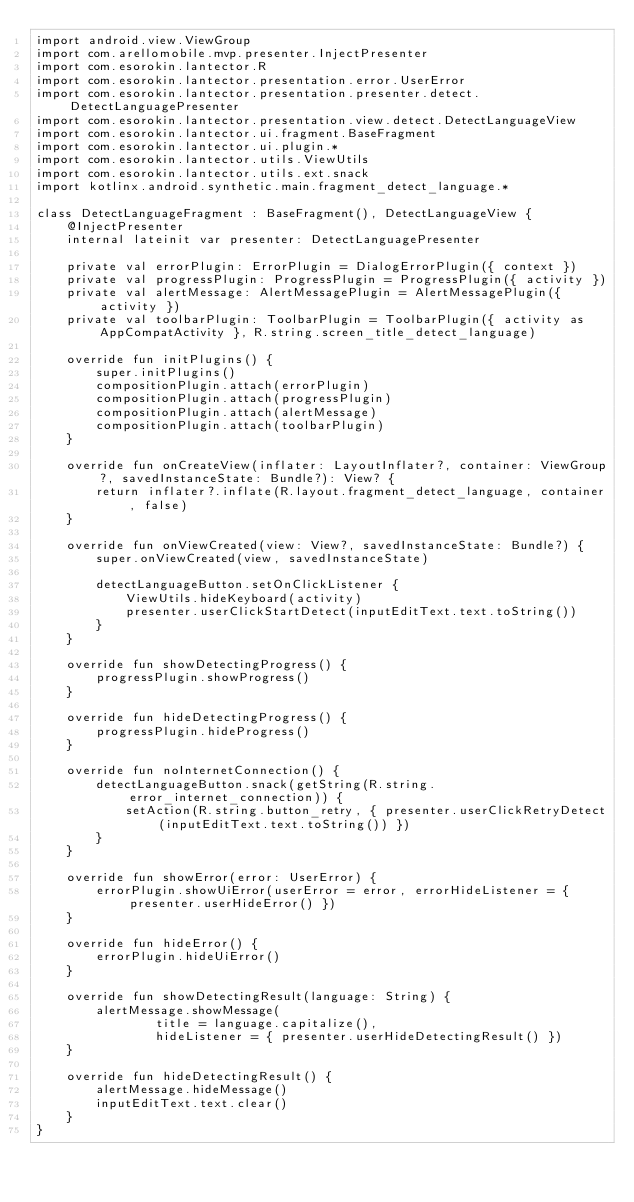<code> <loc_0><loc_0><loc_500><loc_500><_Kotlin_>import android.view.ViewGroup
import com.arellomobile.mvp.presenter.InjectPresenter
import com.esorokin.lantector.R
import com.esorokin.lantector.presentation.error.UserError
import com.esorokin.lantector.presentation.presenter.detect.DetectLanguagePresenter
import com.esorokin.lantector.presentation.view.detect.DetectLanguageView
import com.esorokin.lantector.ui.fragment.BaseFragment
import com.esorokin.lantector.ui.plugin.*
import com.esorokin.lantector.utils.ViewUtils
import com.esorokin.lantector.utils.ext.snack
import kotlinx.android.synthetic.main.fragment_detect_language.*

class DetectLanguageFragment : BaseFragment(), DetectLanguageView {
    @InjectPresenter
    internal lateinit var presenter: DetectLanguagePresenter

    private val errorPlugin: ErrorPlugin = DialogErrorPlugin({ context })
    private val progressPlugin: ProgressPlugin = ProgressPlugin({ activity })
    private val alertMessage: AlertMessagePlugin = AlertMessagePlugin({ activity })
    private val toolbarPlugin: ToolbarPlugin = ToolbarPlugin({ activity as AppCompatActivity }, R.string.screen_title_detect_language)

    override fun initPlugins() {
        super.initPlugins()
        compositionPlugin.attach(errorPlugin)
        compositionPlugin.attach(progressPlugin)
        compositionPlugin.attach(alertMessage)
        compositionPlugin.attach(toolbarPlugin)
    }

    override fun onCreateView(inflater: LayoutInflater?, container: ViewGroup?, savedInstanceState: Bundle?): View? {
        return inflater?.inflate(R.layout.fragment_detect_language, container, false)
    }

    override fun onViewCreated(view: View?, savedInstanceState: Bundle?) {
        super.onViewCreated(view, savedInstanceState)

        detectLanguageButton.setOnClickListener {
            ViewUtils.hideKeyboard(activity)
            presenter.userClickStartDetect(inputEditText.text.toString())
        }
    }

    override fun showDetectingProgress() {
        progressPlugin.showProgress()
    }

    override fun hideDetectingProgress() {
        progressPlugin.hideProgress()
    }

    override fun noInternetConnection() {
        detectLanguageButton.snack(getString(R.string.error_internet_connection)) {
            setAction(R.string.button_retry, { presenter.userClickRetryDetect(inputEditText.text.toString()) })
        }
    }

    override fun showError(error: UserError) {
        errorPlugin.showUiError(userError = error, errorHideListener = { presenter.userHideError() })
    }

    override fun hideError() {
        errorPlugin.hideUiError()
    }

    override fun showDetectingResult(language: String) {
        alertMessage.showMessage(
                title = language.capitalize(),
                hideListener = { presenter.userHideDetectingResult() })
    }

    override fun hideDetectingResult() {
        alertMessage.hideMessage()
        inputEditText.text.clear()
    }
}
</code> 